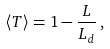Convert formula to latex. <formula><loc_0><loc_0><loc_500><loc_500>\langle T \rangle = 1 - \frac { L } { L _ { d } } \, ,</formula> 